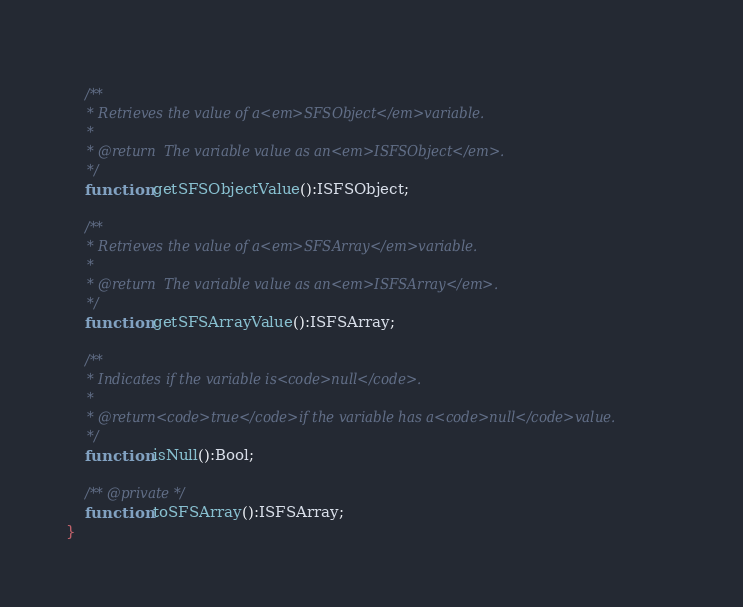Convert code to text. <code><loc_0><loc_0><loc_500><loc_500><_Haxe_>	
	/**
	 * Retrieves the value of a<em>SFSObject</em>variable.
	 * 
	 * @return  The variable value as an<em>ISFSObject</em>.
	 */
	function getSFSObjectValue():ISFSObject;
	
	/**
	 * Retrieves the value of a<em>SFSArray</em>variable.
	 * 
	 * @return  The variable value as an<em>ISFSArray</em>.
	 */
	function getSFSArrayValue():ISFSArray;
	
	/**
	 * Indicates if the variable is<code>null</code>.
	 * 
	 * @return<code>true</code>if the variable has a<code>null</code>value.
	 */
	function isNull():Bool;
	
	/** @private */
	function toSFSArray():ISFSArray;
}</code> 